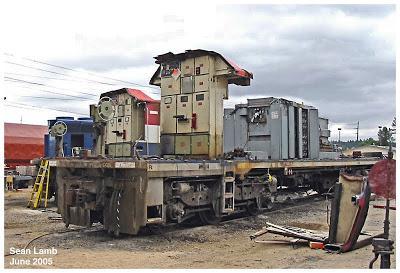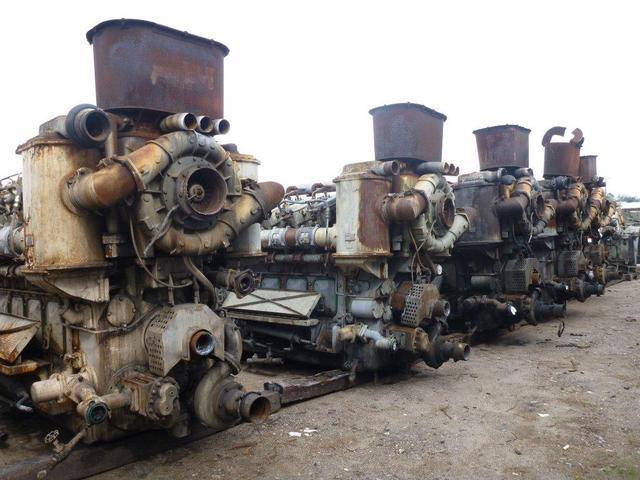The first image is the image on the left, the second image is the image on the right. Considering the images on both sides, is "The image on the right contains a vehicle with black and white stripes." valid? Answer yes or no. No. 